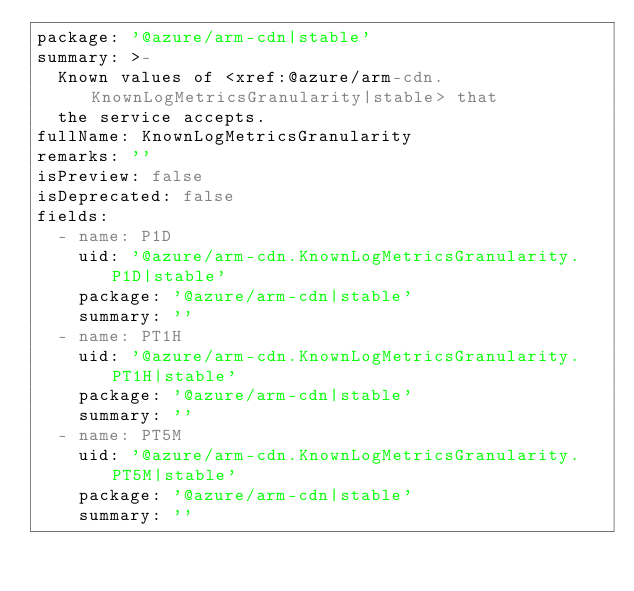<code> <loc_0><loc_0><loc_500><loc_500><_YAML_>package: '@azure/arm-cdn|stable'
summary: >-
  Known values of <xref:@azure/arm-cdn.KnownLogMetricsGranularity|stable> that
  the service accepts.
fullName: KnownLogMetricsGranularity
remarks: ''
isPreview: false
isDeprecated: false
fields:
  - name: P1D
    uid: '@azure/arm-cdn.KnownLogMetricsGranularity.P1D|stable'
    package: '@azure/arm-cdn|stable'
    summary: ''
  - name: PT1H
    uid: '@azure/arm-cdn.KnownLogMetricsGranularity.PT1H|stable'
    package: '@azure/arm-cdn|stable'
    summary: ''
  - name: PT5M
    uid: '@azure/arm-cdn.KnownLogMetricsGranularity.PT5M|stable'
    package: '@azure/arm-cdn|stable'
    summary: ''
</code> 